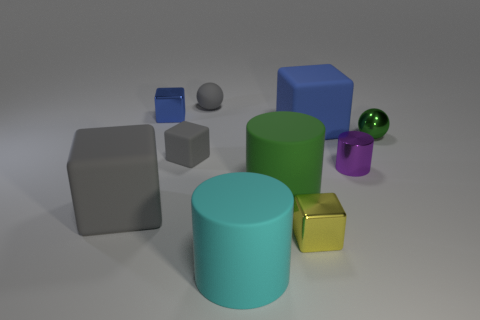What is the shape of the rubber thing that is the same color as the tiny shiny ball?
Offer a very short reply. Cylinder. Is the size of the gray block behind the green cylinder the same as the rubber block left of the tiny gray cube?
Make the answer very short. No. How many other objects are there of the same size as the gray rubber sphere?
Give a very brief answer. 5. How many things are either rubber blocks that are left of the tiny blue shiny thing or large objects that are left of the small blue shiny block?
Offer a very short reply. 1. Is the material of the large gray block the same as the large thing in front of the yellow metal cube?
Keep it short and to the point. Yes. How many other things are there of the same shape as the small purple thing?
Offer a terse response. 2. The sphere that is to the right of the rubber object that is in front of the small yellow cube in front of the rubber ball is made of what material?
Keep it short and to the point. Metal. Are there the same number of purple metal cylinders in front of the cyan matte cylinder and brown cubes?
Your answer should be very brief. Yes. Are the large object in front of the yellow block and the sphere that is in front of the tiny matte ball made of the same material?
Your response must be concise. No. Are there any other things that are the same material as the cyan object?
Offer a very short reply. Yes. 